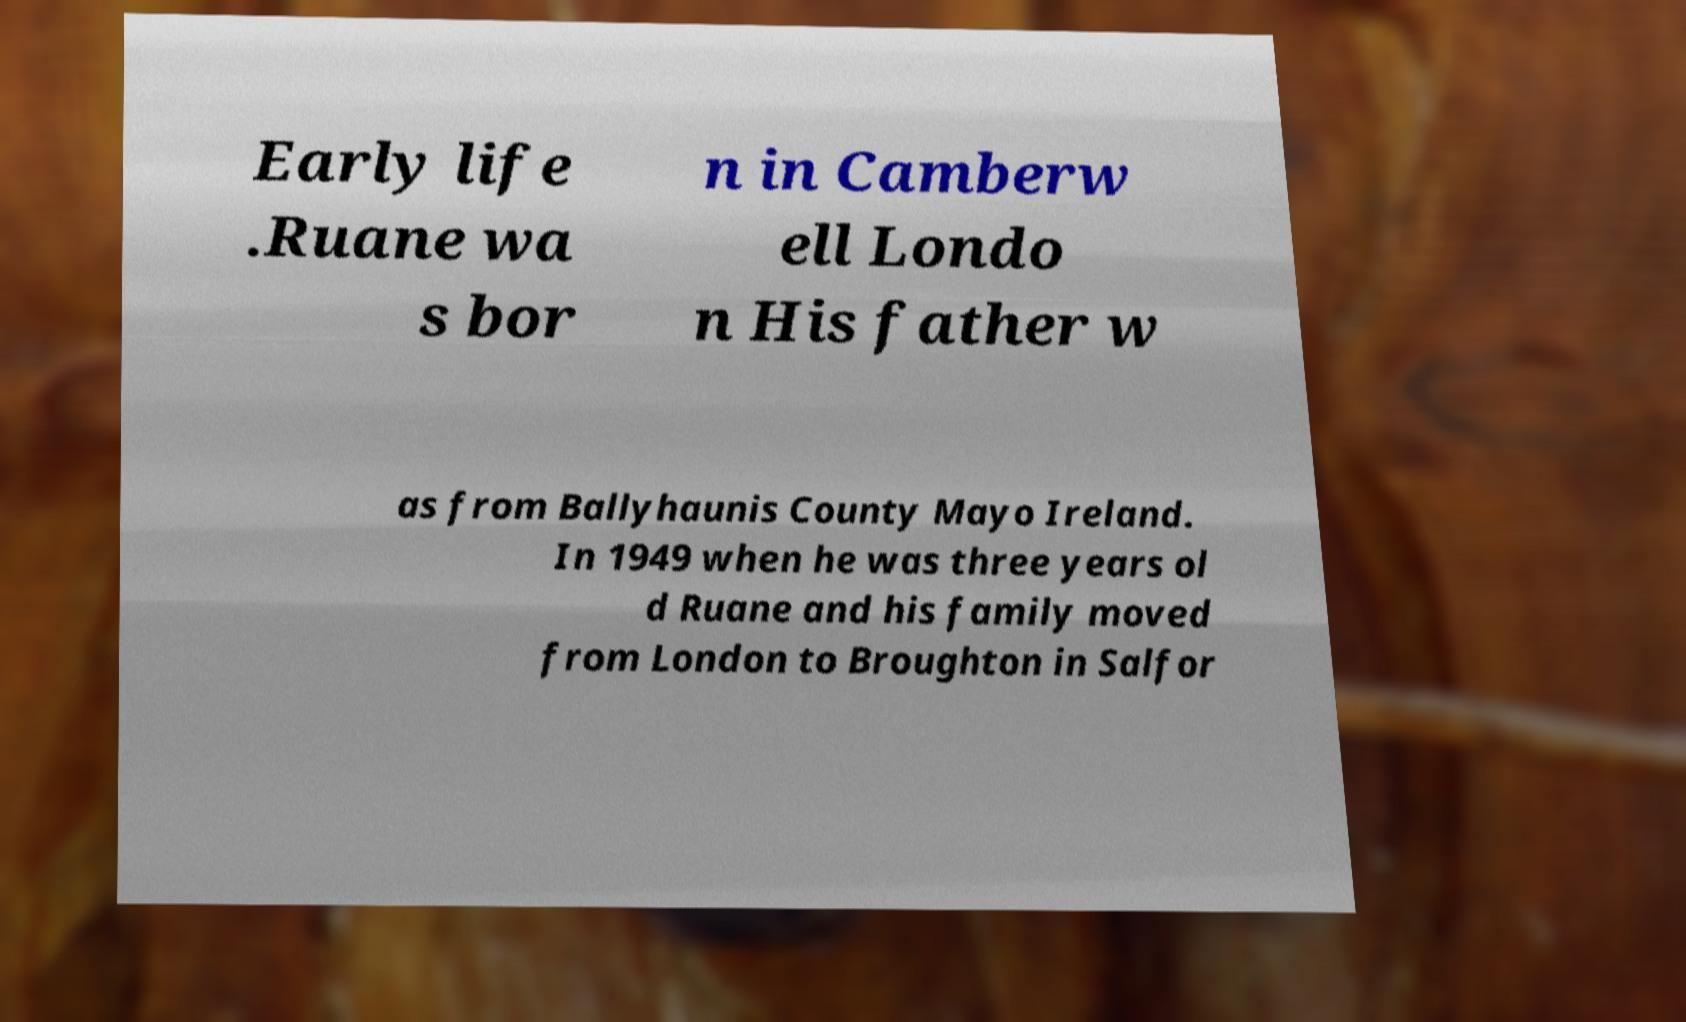There's text embedded in this image that I need extracted. Can you transcribe it verbatim? Early life .Ruane wa s bor n in Camberw ell Londo n His father w as from Ballyhaunis County Mayo Ireland. In 1949 when he was three years ol d Ruane and his family moved from London to Broughton in Salfor 